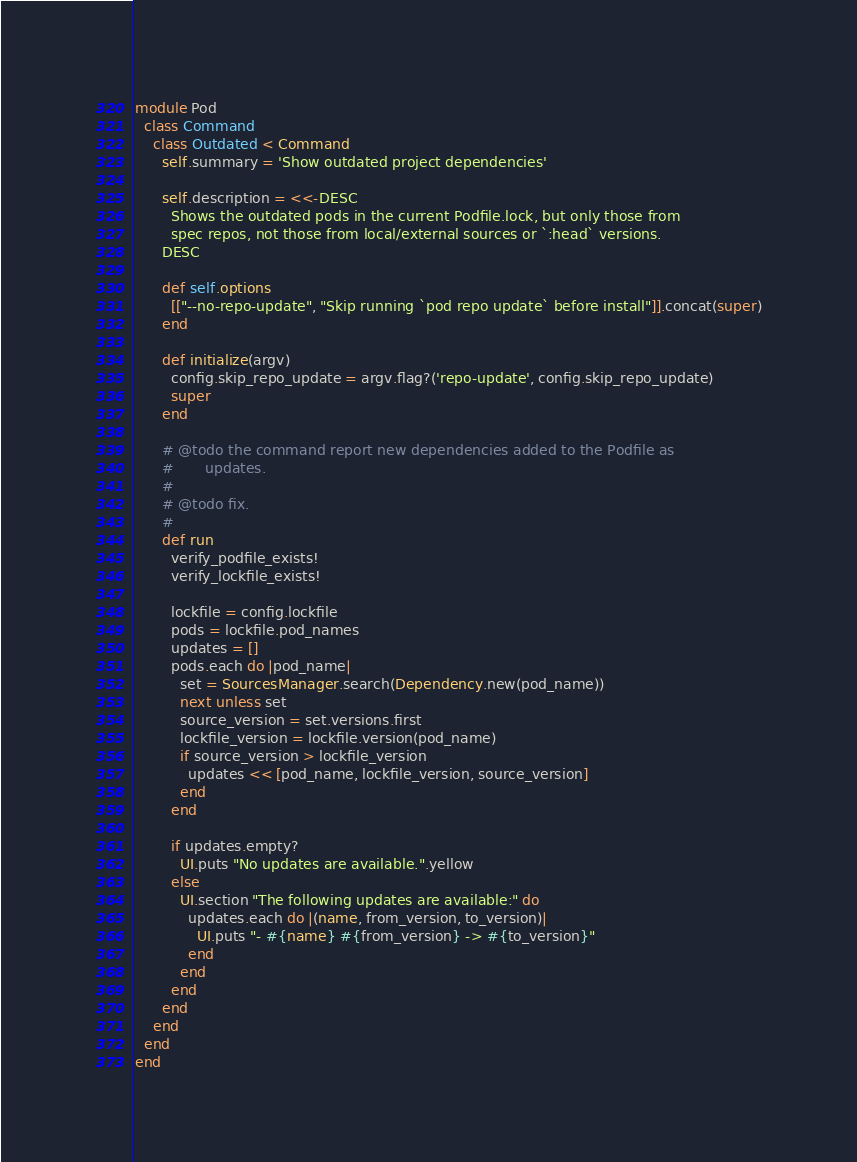Convert code to text. <code><loc_0><loc_0><loc_500><loc_500><_Ruby_>module Pod
  class Command
    class Outdated < Command
      self.summary = 'Show outdated project dependencies'

      self.description = <<-DESC
        Shows the outdated pods in the current Podfile.lock, but only those from
        spec repos, not those from local/external sources or `:head` versions.
      DESC

      def self.options
        [["--no-repo-update", "Skip running `pod repo update` before install"]].concat(super)
      end

      def initialize(argv)
        config.skip_repo_update = argv.flag?('repo-update', config.skip_repo_update)
        super
      end

      # @todo the command report new dependencies added to the Podfile as
      #       updates.
      #
      # @todo fix.
      #
      def run
        verify_podfile_exists!
        verify_lockfile_exists!

        lockfile = config.lockfile
        pods = lockfile.pod_names
        updates = []
        pods.each do |pod_name|
          set = SourcesManager.search(Dependency.new(pod_name))
          next unless set
          source_version = set.versions.first
          lockfile_version = lockfile.version(pod_name)
          if source_version > lockfile_version
            updates << [pod_name, lockfile_version, source_version]
          end
        end

        if updates.empty?
          UI.puts "No updates are available.".yellow
        else
          UI.section "The following updates are available:" do
            updates.each do |(name, from_version, to_version)|
              UI.puts "- #{name} #{from_version} -> #{to_version}"
            end
          end
        end
      end
    end
  end
end


</code> 